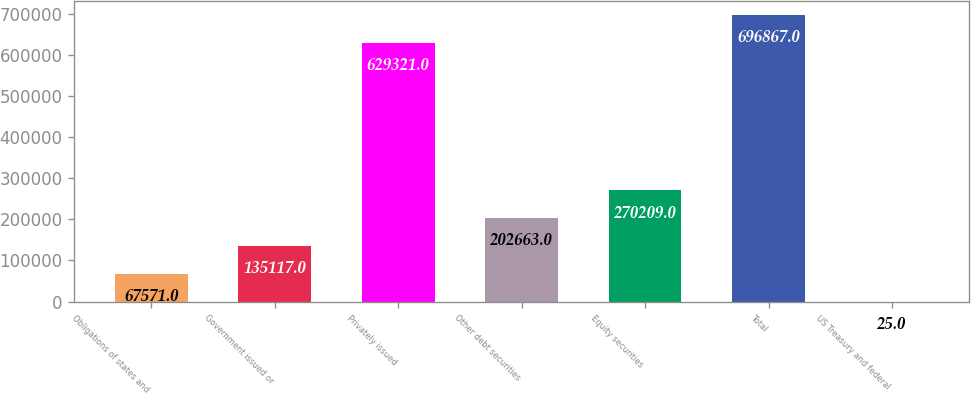Convert chart to OTSL. <chart><loc_0><loc_0><loc_500><loc_500><bar_chart><fcel>Obligations of states and<fcel>Government issued or<fcel>Privately issued<fcel>Other debt securities<fcel>Equity securities<fcel>Total<fcel>US Treasury and federal<nl><fcel>67571<fcel>135117<fcel>629321<fcel>202663<fcel>270209<fcel>696867<fcel>25<nl></chart> 